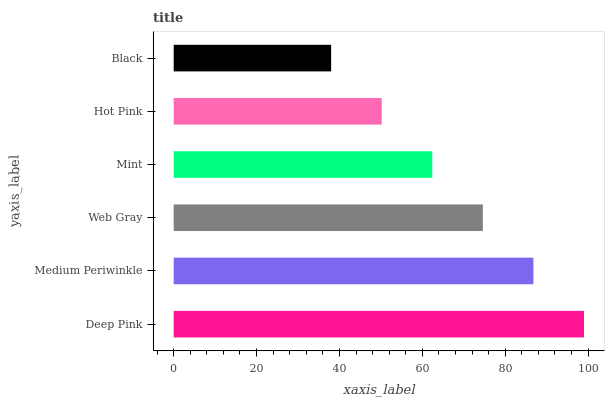Is Black the minimum?
Answer yes or no. Yes. Is Deep Pink the maximum?
Answer yes or no. Yes. Is Medium Periwinkle the minimum?
Answer yes or no. No. Is Medium Periwinkle the maximum?
Answer yes or no. No. Is Deep Pink greater than Medium Periwinkle?
Answer yes or no. Yes. Is Medium Periwinkle less than Deep Pink?
Answer yes or no. Yes. Is Medium Periwinkle greater than Deep Pink?
Answer yes or no. No. Is Deep Pink less than Medium Periwinkle?
Answer yes or no. No. Is Web Gray the high median?
Answer yes or no. Yes. Is Mint the low median?
Answer yes or no. Yes. Is Deep Pink the high median?
Answer yes or no. No. Is Medium Periwinkle the low median?
Answer yes or no. No. 